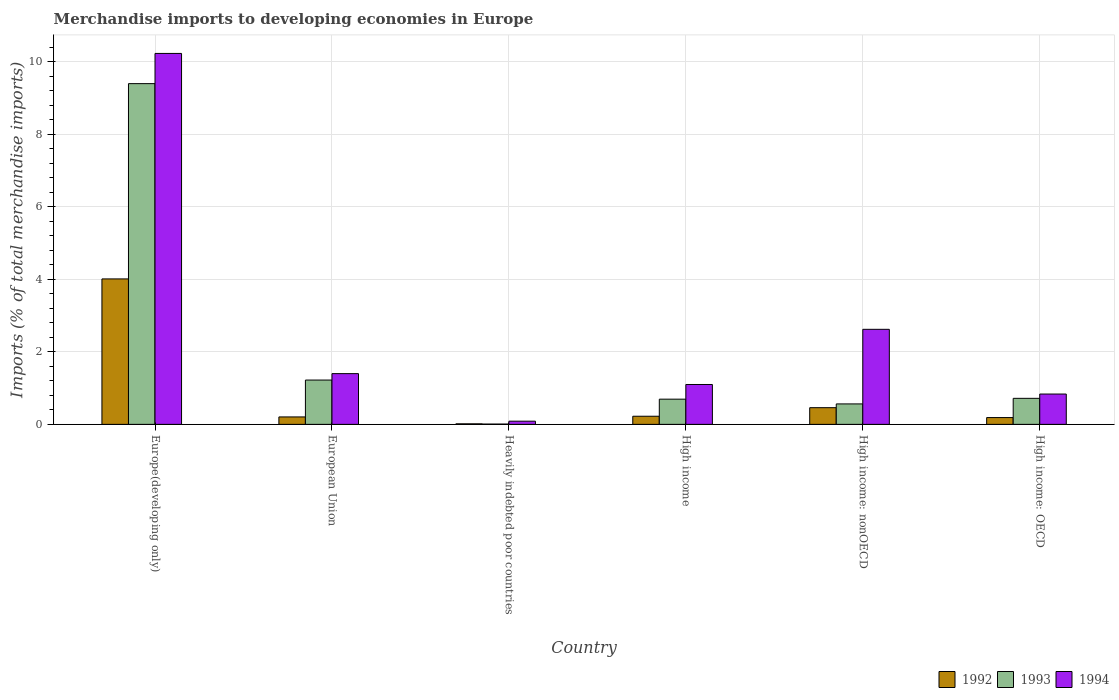How many different coloured bars are there?
Provide a short and direct response. 3. How many groups of bars are there?
Ensure brevity in your answer.  6. Are the number of bars per tick equal to the number of legend labels?
Give a very brief answer. Yes. Are the number of bars on each tick of the X-axis equal?
Offer a terse response. Yes. How many bars are there on the 4th tick from the left?
Keep it short and to the point. 3. In how many cases, is the number of bars for a given country not equal to the number of legend labels?
Your answer should be very brief. 0. What is the percentage total merchandise imports in 1994 in High income: OECD?
Keep it short and to the point. 0.84. Across all countries, what is the maximum percentage total merchandise imports in 1994?
Offer a terse response. 10.23. Across all countries, what is the minimum percentage total merchandise imports in 1993?
Your answer should be very brief. 0.01. In which country was the percentage total merchandise imports in 1992 maximum?
Give a very brief answer. Europe(developing only). In which country was the percentage total merchandise imports in 1993 minimum?
Keep it short and to the point. Heavily indebted poor countries. What is the total percentage total merchandise imports in 1994 in the graph?
Your response must be concise. 16.27. What is the difference between the percentage total merchandise imports in 1992 in European Union and that in High income?
Make the answer very short. -0.02. What is the difference between the percentage total merchandise imports in 1994 in High income and the percentage total merchandise imports in 1993 in Heavily indebted poor countries?
Your answer should be very brief. 1.09. What is the average percentage total merchandise imports in 1993 per country?
Your answer should be very brief. 2.1. What is the difference between the percentage total merchandise imports of/in 1992 and percentage total merchandise imports of/in 1994 in European Union?
Ensure brevity in your answer.  -1.19. In how many countries, is the percentage total merchandise imports in 1994 greater than 3.2 %?
Your response must be concise. 1. What is the ratio of the percentage total merchandise imports in 1994 in European Union to that in High income: nonOECD?
Your response must be concise. 0.53. What is the difference between the highest and the second highest percentage total merchandise imports in 1992?
Give a very brief answer. 0.24. What is the difference between the highest and the lowest percentage total merchandise imports in 1994?
Your response must be concise. 10.14. In how many countries, is the percentage total merchandise imports in 1992 greater than the average percentage total merchandise imports in 1992 taken over all countries?
Keep it short and to the point. 1. Is the sum of the percentage total merchandise imports in 1994 in European Union and High income greater than the maximum percentage total merchandise imports in 1993 across all countries?
Make the answer very short. No. What does the 3rd bar from the right in High income represents?
Keep it short and to the point. 1992. How many bars are there?
Provide a short and direct response. 18. Are all the bars in the graph horizontal?
Give a very brief answer. No. Are the values on the major ticks of Y-axis written in scientific E-notation?
Provide a succinct answer. No. Where does the legend appear in the graph?
Give a very brief answer. Bottom right. What is the title of the graph?
Offer a very short reply. Merchandise imports to developing economies in Europe. What is the label or title of the X-axis?
Keep it short and to the point. Country. What is the label or title of the Y-axis?
Offer a very short reply. Imports (% of total merchandise imports). What is the Imports (% of total merchandise imports) of 1992 in Europe(developing only)?
Provide a short and direct response. 4.01. What is the Imports (% of total merchandise imports) of 1993 in Europe(developing only)?
Your answer should be compact. 9.39. What is the Imports (% of total merchandise imports) in 1994 in Europe(developing only)?
Provide a short and direct response. 10.23. What is the Imports (% of total merchandise imports) of 1992 in European Union?
Offer a very short reply. 0.21. What is the Imports (% of total merchandise imports) in 1993 in European Union?
Your answer should be very brief. 1.22. What is the Imports (% of total merchandise imports) of 1994 in European Union?
Give a very brief answer. 1.4. What is the Imports (% of total merchandise imports) in 1992 in Heavily indebted poor countries?
Make the answer very short. 0.02. What is the Imports (% of total merchandise imports) of 1993 in Heavily indebted poor countries?
Your answer should be compact. 0.01. What is the Imports (% of total merchandise imports) in 1994 in Heavily indebted poor countries?
Provide a succinct answer. 0.09. What is the Imports (% of total merchandise imports) of 1992 in High income?
Keep it short and to the point. 0.22. What is the Imports (% of total merchandise imports) of 1993 in High income?
Give a very brief answer. 0.7. What is the Imports (% of total merchandise imports) of 1994 in High income?
Provide a succinct answer. 1.1. What is the Imports (% of total merchandise imports) in 1992 in High income: nonOECD?
Provide a short and direct response. 0.46. What is the Imports (% of total merchandise imports) of 1993 in High income: nonOECD?
Your answer should be very brief. 0.56. What is the Imports (% of total merchandise imports) in 1994 in High income: nonOECD?
Make the answer very short. 2.62. What is the Imports (% of total merchandise imports) in 1992 in High income: OECD?
Your answer should be very brief. 0.19. What is the Imports (% of total merchandise imports) of 1993 in High income: OECD?
Offer a terse response. 0.72. What is the Imports (% of total merchandise imports) in 1994 in High income: OECD?
Your response must be concise. 0.84. Across all countries, what is the maximum Imports (% of total merchandise imports) in 1992?
Provide a succinct answer. 4.01. Across all countries, what is the maximum Imports (% of total merchandise imports) in 1993?
Ensure brevity in your answer.  9.39. Across all countries, what is the maximum Imports (% of total merchandise imports) in 1994?
Keep it short and to the point. 10.23. Across all countries, what is the minimum Imports (% of total merchandise imports) of 1992?
Offer a very short reply. 0.02. Across all countries, what is the minimum Imports (% of total merchandise imports) in 1993?
Your response must be concise. 0.01. Across all countries, what is the minimum Imports (% of total merchandise imports) in 1994?
Ensure brevity in your answer.  0.09. What is the total Imports (% of total merchandise imports) in 1992 in the graph?
Ensure brevity in your answer.  5.1. What is the total Imports (% of total merchandise imports) in 1993 in the graph?
Your response must be concise. 12.6. What is the total Imports (% of total merchandise imports) in 1994 in the graph?
Give a very brief answer. 16.27. What is the difference between the Imports (% of total merchandise imports) of 1992 in Europe(developing only) and that in European Union?
Keep it short and to the point. 3.8. What is the difference between the Imports (% of total merchandise imports) in 1993 in Europe(developing only) and that in European Union?
Your response must be concise. 8.17. What is the difference between the Imports (% of total merchandise imports) in 1994 in Europe(developing only) and that in European Union?
Keep it short and to the point. 8.83. What is the difference between the Imports (% of total merchandise imports) of 1992 in Europe(developing only) and that in Heavily indebted poor countries?
Your answer should be very brief. 4. What is the difference between the Imports (% of total merchandise imports) of 1993 in Europe(developing only) and that in Heavily indebted poor countries?
Your answer should be very brief. 9.39. What is the difference between the Imports (% of total merchandise imports) in 1994 in Europe(developing only) and that in Heavily indebted poor countries?
Give a very brief answer. 10.14. What is the difference between the Imports (% of total merchandise imports) of 1992 in Europe(developing only) and that in High income?
Provide a short and direct response. 3.79. What is the difference between the Imports (% of total merchandise imports) in 1993 in Europe(developing only) and that in High income?
Offer a terse response. 8.7. What is the difference between the Imports (% of total merchandise imports) of 1994 in Europe(developing only) and that in High income?
Provide a succinct answer. 9.13. What is the difference between the Imports (% of total merchandise imports) in 1992 in Europe(developing only) and that in High income: nonOECD?
Make the answer very short. 3.55. What is the difference between the Imports (% of total merchandise imports) in 1993 in Europe(developing only) and that in High income: nonOECD?
Keep it short and to the point. 8.83. What is the difference between the Imports (% of total merchandise imports) of 1994 in Europe(developing only) and that in High income: nonOECD?
Your answer should be compact. 7.61. What is the difference between the Imports (% of total merchandise imports) of 1992 in Europe(developing only) and that in High income: OECD?
Provide a succinct answer. 3.82. What is the difference between the Imports (% of total merchandise imports) of 1993 in Europe(developing only) and that in High income: OECD?
Provide a short and direct response. 8.68. What is the difference between the Imports (% of total merchandise imports) of 1994 in Europe(developing only) and that in High income: OECD?
Provide a short and direct response. 9.39. What is the difference between the Imports (% of total merchandise imports) in 1992 in European Union and that in Heavily indebted poor countries?
Provide a succinct answer. 0.19. What is the difference between the Imports (% of total merchandise imports) in 1993 in European Union and that in Heavily indebted poor countries?
Your response must be concise. 1.21. What is the difference between the Imports (% of total merchandise imports) in 1994 in European Union and that in Heavily indebted poor countries?
Offer a terse response. 1.31. What is the difference between the Imports (% of total merchandise imports) in 1992 in European Union and that in High income?
Offer a terse response. -0.02. What is the difference between the Imports (% of total merchandise imports) in 1993 in European Union and that in High income?
Ensure brevity in your answer.  0.53. What is the difference between the Imports (% of total merchandise imports) of 1994 in European Union and that in High income?
Offer a very short reply. 0.3. What is the difference between the Imports (% of total merchandise imports) of 1992 in European Union and that in High income: nonOECD?
Make the answer very short. -0.25. What is the difference between the Imports (% of total merchandise imports) of 1993 in European Union and that in High income: nonOECD?
Provide a succinct answer. 0.66. What is the difference between the Imports (% of total merchandise imports) in 1994 in European Union and that in High income: nonOECD?
Provide a succinct answer. -1.22. What is the difference between the Imports (% of total merchandise imports) of 1992 in European Union and that in High income: OECD?
Provide a succinct answer. 0.02. What is the difference between the Imports (% of total merchandise imports) of 1993 in European Union and that in High income: OECD?
Keep it short and to the point. 0.5. What is the difference between the Imports (% of total merchandise imports) in 1994 in European Union and that in High income: OECD?
Ensure brevity in your answer.  0.56. What is the difference between the Imports (% of total merchandise imports) in 1992 in Heavily indebted poor countries and that in High income?
Offer a very short reply. -0.21. What is the difference between the Imports (% of total merchandise imports) of 1993 in Heavily indebted poor countries and that in High income?
Your answer should be very brief. -0.69. What is the difference between the Imports (% of total merchandise imports) in 1994 in Heavily indebted poor countries and that in High income?
Ensure brevity in your answer.  -1.01. What is the difference between the Imports (% of total merchandise imports) in 1992 in Heavily indebted poor countries and that in High income: nonOECD?
Provide a short and direct response. -0.45. What is the difference between the Imports (% of total merchandise imports) of 1993 in Heavily indebted poor countries and that in High income: nonOECD?
Provide a short and direct response. -0.56. What is the difference between the Imports (% of total merchandise imports) of 1994 in Heavily indebted poor countries and that in High income: nonOECD?
Your answer should be very brief. -2.53. What is the difference between the Imports (% of total merchandise imports) in 1992 in Heavily indebted poor countries and that in High income: OECD?
Your answer should be very brief. -0.17. What is the difference between the Imports (% of total merchandise imports) of 1993 in Heavily indebted poor countries and that in High income: OECD?
Keep it short and to the point. -0.71. What is the difference between the Imports (% of total merchandise imports) in 1994 in Heavily indebted poor countries and that in High income: OECD?
Offer a very short reply. -0.75. What is the difference between the Imports (% of total merchandise imports) in 1992 in High income and that in High income: nonOECD?
Provide a short and direct response. -0.24. What is the difference between the Imports (% of total merchandise imports) in 1993 in High income and that in High income: nonOECD?
Keep it short and to the point. 0.13. What is the difference between the Imports (% of total merchandise imports) of 1994 in High income and that in High income: nonOECD?
Offer a terse response. -1.52. What is the difference between the Imports (% of total merchandise imports) in 1992 in High income and that in High income: OECD?
Your response must be concise. 0.04. What is the difference between the Imports (% of total merchandise imports) in 1993 in High income and that in High income: OECD?
Provide a succinct answer. -0.02. What is the difference between the Imports (% of total merchandise imports) in 1994 in High income and that in High income: OECD?
Offer a very short reply. 0.26. What is the difference between the Imports (% of total merchandise imports) of 1992 in High income: nonOECD and that in High income: OECD?
Your answer should be compact. 0.27. What is the difference between the Imports (% of total merchandise imports) of 1993 in High income: nonOECD and that in High income: OECD?
Keep it short and to the point. -0.15. What is the difference between the Imports (% of total merchandise imports) in 1994 in High income: nonOECD and that in High income: OECD?
Provide a succinct answer. 1.78. What is the difference between the Imports (% of total merchandise imports) in 1992 in Europe(developing only) and the Imports (% of total merchandise imports) in 1993 in European Union?
Your answer should be compact. 2.79. What is the difference between the Imports (% of total merchandise imports) of 1992 in Europe(developing only) and the Imports (% of total merchandise imports) of 1994 in European Union?
Offer a terse response. 2.61. What is the difference between the Imports (% of total merchandise imports) in 1993 in Europe(developing only) and the Imports (% of total merchandise imports) in 1994 in European Union?
Provide a succinct answer. 8. What is the difference between the Imports (% of total merchandise imports) of 1992 in Europe(developing only) and the Imports (% of total merchandise imports) of 1993 in Heavily indebted poor countries?
Your answer should be very brief. 4. What is the difference between the Imports (% of total merchandise imports) of 1992 in Europe(developing only) and the Imports (% of total merchandise imports) of 1994 in Heavily indebted poor countries?
Provide a short and direct response. 3.92. What is the difference between the Imports (% of total merchandise imports) in 1993 in Europe(developing only) and the Imports (% of total merchandise imports) in 1994 in Heavily indebted poor countries?
Your answer should be very brief. 9.31. What is the difference between the Imports (% of total merchandise imports) of 1992 in Europe(developing only) and the Imports (% of total merchandise imports) of 1993 in High income?
Make the answer very short. 3.32. What is the difference between the Imports (% of total merchandise imports) in 1992 in Europe(developing only) and the Imports (% of total merchandise imports) in 1994 in High income?
Ensure brevity in your answer.  2.91. What is the difference between the Imports (% of total merchandise imports) in 1993 in Europe(developing only) and the Imports (% of total merchandise imports) in 1994 in High income?
Provide a short and direct response. 8.29. What is the difference between the Imports (% of total merchandise imports) of 1992 in Europe(developing only) and the Imports (% of total merchandise imports) of 1993 in High income: nonOECD?
Your response must be concise. 3.45. What is the difference between the Imports (% of total merchandise imports) in 1992 in Europe(developing only) and the Imports (% of total merchandise imports) in 1994 in High income: nonOECD?
Make the answer very short. 1.39. What is the difference between the Imports (% of total merchandise imports) of 1993 in Europe(developing only) and the Imports (% of total merchandise imports) of 1994 in High income: nonOECD?
Your answer should be compact. 6.77. What is the difference between the Imports (% of total merchandise imports) of 1992 in Europe(developing only) and the Imports (% of total merchandise imports) of 1993 in High income: OECD?
Keep it short and to the point. 3.29. What is the difference between the Imports (% of total merchandise imports) in 1992 in Europe(developing only) and the Imports (% of total merchandise imports) in 1994 in High income: OECD?
Your response must be concise. 3.17. What is the difference between the Imports (% of total merchandise imports) in 1993 in Europe(developing only) and the Imports (% of total merchandise imports) in 1994 in High income: OECD?
Offer a terse response. 8.56. What is the difference between the Imports (% of total merchandise imports) in 1992 in European Union and the Imports (% of total merchandise imports) in 1993 in Heavily indebted poor countries?
Make the answer very short. 0.2. What is the difference between the Imports (% of total merchandise imports) in 1992 in European Union and the Imports (% of total merchandise imports) in 1994 in Heavily indebted poor countries?
Offer a very short reply. 0.12. What is the difference between the Imports (% of total merchandise imports) in 1993 in European Union and the Imports (% of total merchandise imports) in 1994 in Heavily indebted poor countries?
Keep it short and to the point. 1.13. What is the difference between the Imports (% of total merchandise imports) of 1992 in European Union and the Imports (% of total merchandise imports) of 1993 in High income?
Your response must be concise. -0.49. What is the difference between the Imports (% of total merchandise imports) of 1992 in European Union and the Imports (% of total merchandise imports) of 1994 in High income?
Provide a short and direct response. -0.89. What is the difference between the Imports (% of total merchandise imports) in 1993 in European Union and the Imports (% of total merchandise imports) in 1994 in High income?
Your response must be concise. 0.12. What is the difference between the Imports (% of total merchandise imports) of 1992 in European Union and the Imports (% of total merchandise imports) of 1993 in High income: nonOECD?
Your answer should be very brief. -0.36. What is the difference between the Imports (% of total merchandise imports) in 1992 in European Union and the Imports (% of total merchandise imports) in 1994 in High income: nonOECD?
Provide a succinct answer. -2.42. What is the difference between the Imports (% of total merchandise imports) of 1993 in European Union and the Imports (% of total merchandise imports) of 1994 in High income: nonOECD?
Offer a terse response. -1.4. What is the difference between the Imports (% of total merchandise imports) in 1992 in European Union and the Imports (% of total merchandise imports) in 1993 in High income: OECD?
Your response must be concise. -0.51. What is the difference between the Imports (% of total merchandise imports) of 1992 in European Union and the Imports (% of total merchandise imports) of 1994 in High income: OECD?
Provide a succinct answer. -0.63. What is the difference between the Imports (% of total merchandise imports) in 1993 in European Union and the Imports (% of total merchandise imports) in 1994 in High income: OECD?
Keep it short and to the point. 0.39. What is the difference between the Imports (% of total merchandise imports) in 1992 in Heavily indebted poor countries and the Imports (% of total merchandise imports) in 1993 in High income?
Ensure brevity in your answer.  -0.68. What is the difference between the Imports (% of total merchandise imports) in 1992 in Heavily indebted poor countries and the Imports (% of total merchandise imports) in 1994 in High income?
Your answer should be very brief. -1.08. What is the difference between the Imports (% of total merchandise imports) of 1993 in Heavily indebted poor countries and the Imports (% of total merchandise imports) of 1994 in High income?
Ensure brevity in your answer.  -1.09. What is the difference between the Imports (% of total merchandise imports) of 1992 in Heavily indebted poor countries and the Imports (% of total merchandise imports) of 1993 in High income: nonOECD?
Offer a very short reply. -0.55. What is the difference between the Imports (% of total merchandise imports) in 1992 in Heavily indebted poor countries and the Imports (% of total merchandise imports) in 1994 in High income: nonOECD?
Your answer should be very brief. -2.61. What is the difference between the Imports (% of total merchandise imports) in 1993 in Heavily indebted poor countries and the Imports (% of total merchandise imports) in 1994 in High income: nonOECD?
Give a very brief answer. -2.61. What is the difference between the Imports (% of total merchandise imports) in 1992 in Heavily indebted poor countries and the Imports (% of total merchandise imports) in 1993 in High income: OECD?
Give a very brief answer. -0.7. What is the difference between the Imports (% of total merchandise imports) of 1992 in Heavily indebted poor countries and the Imports (% of total merchandise imports) of 1994 in High income: OECD?
Make the answer very short. -0.82. What is the difference between the Imports (% of total merchandise imports) of 1993 in Heavily indebted poor countries and the Imports (% of total merchandise imports) of 1994 in High income: OECD?
Your answer should be very brief. -0.83. What is the difference between the Imports (% of total merchandise imports) in 1992 in High income and the Imports (% of total merchandise imports) in 1993 in High income: nonOECD?
Your answer should be compact. -0.34. What is the difference between the Imports (% of total merchandise imports) of 1992 in High income and the Imports (% of total merchandise imports) of 1994 in High income: nonOECD?
Provide a succinct answer. -2.4. What is the difference between the Imports (% of total merchandise imports) of 1993 in High income and the Imports (% of total merchandise imports) of 1994 in High income: nonOECD?
Your answer should be compact. -1.93. What is the difference between the Imports (% of total merchandise imports) of 1992 in High income and the Imports (% of total merchandise imports) of 1993 in High income: OECD?
Keep it short and to the point. -0.49. What is the difference between the Imports (% of total merchandise imports) of 1992 in High income and the Imports (% of total merchandise imports) of 1994 in High income: OECD?
Provide a succinct answer. -0.61. What is the difference between the Imports (% of total merchandise imports) in 1993 in High income and the Imports (% of total merchandise imports) in 1994 in High income: OECD?
Ensure brevity in your answer.  -0.14. What is the difference between the Imports (% of total merchandise imports) of 1992 in High income: nonOECD and the Imports (% of total merchandise imports) of 1993 in High income: OECD?
Give a very brief answer. -0.26. What is the difference between the Imports (% of total merchandise imports) of 1992 in High income: nonOECD and the Imports (% of total merchandise imports) of 1994 in High income: OECD?
Keep it short and to the point. -0.38. What is the difference between the Imports (% of total merchandise imports) in 1993 in High income: nonOECD and the Imports (% of total merchandise imports) in 1994 in High income: OECD?
Make the answer very short. -0.27. What is the average Imports (% of total merchandise imports) in 1992 per country?
Give a very brief answer. 0.85. What is the average Imports (% of total merchandise imports) in 1993 per country?
Keep it short and to the point. 2.1. What is the average Imports (% of total merchandise imports) in 1994 per country?
Ensure brevity in your answer.  2.71. What is the difference between the Imports (% of total merchandise imports) in 1992 and Imports (% of total merchandise imports) in 1993 in Europe(developing only)?
Give a very brief answer. -5.38. What is the difference between the Imports (% of total merchandise imports) in 1992 and Imports (% of total merchandise imports) in 1994 in Europe(developing only)?
Offer a terse response. -6.22. What is the difference between the Imports (% of total merchandise imports) of 1993 and Imports (% of total merchandise imports) of 1994 in Europe(developing only)?
Ensure brevity in your answer.  -0.83. What is the difference between the Imports (% of total merchandise imports) of 1992 and Imports (% of total merchandise imports) of 1993 in European Union?
Provide a succinct answer. -1.02. What is the difference between the Imports (% of total merchandise imports) of 1992 and Imports (% of total merchandise imports) of 1994 in European Union?
Offer a terse response. -1.19. What is the difference between the Imports (% of total merchandise imports) of 1993 and Imports (% of total merchandise imports) of 1994 in European Union?
Keep it short and to the point. -0.18. What is the difference between the Imports (% of total merchandise imports) of 1992 and Imports (% of total merchandise imports) of 1993 in Heavily indebted poor countries?
Your answer should be very brief. 0.01. What is the difference between the Imports (% of total merchandise imports) in 1992 and Imports (% of total merchandise imports) in 1994 in Heavily indebted poor countries?
Provide a short and direct response. -0.07. What is the difference between the Imports (% of total merchandise imports) in 1993 and Imports (% of total merchandise imports) in 1994 in Heavily indebted poor countries?
Provide a short and direct response. -0.08. What is the difference between the Imports (% of total merchandise imports) of 1992 and Imports (% of total merchandise imports) of 1993 in High income?
Make the answer very short. -0.47. What is the difference between the Imports (% of total merchandise imports) in 1992 and Imports (% of total merchandise imports) in 1994 in High income?
Ensure brevity in your answer.  -0.88. What is the difference between the Imports (% of total merchandise imports) in 1993 and Imports (% of total merchandise imports) in 1994 in High income?
Make the answer very short. -0.4. What is the difference between the Imports (% of total merchandise imports) in 1992 and Imports (% of total merchandise imports) in 1993 in High income: nonOECD?
Provide a short and direct response. -0.1. What is the difference between the Imports (% of total merchandise imports) of 1992 and Imports (% of total merchandise imports) of 1994 in High income: nonOECD?
Offer a terse response. -2.16. What is the difference between the Imports (% of total merchandise imports) of 1993 and Imports (% of total merchandise imports) of 1994 in High income: nonOECD?
Ensure brevity in your answer.  -2.06. What is the difference between the Imports (% of total merchandise imports) in 1992 and Imports (% of total merchandise imports) in 1993 in High income: OECD?
Provide a succinct answer. -0.53. What is the difference between the Imports (% of total merchandise imports) in 1992 and Imports (% of total merchandise imports) in 1994 in High income: OECD?
Ensure brevity in your answer.  -0.65. What is the difference between the Imports (% of total merchandise imports) of 1993 and Imports (% of total merchandise imports) of 1994 in High income: OECD?
Offer a terse response. -0.12. What is the ratio of the Imports (% of total merchandise imports) in 1992 in Europe(developing only) to that in European Union?
Provide a short and direct response. 19.52. What is the ratio of the Imports (% of total merchandise imports) of 1993 in Europe(developing only) to that in European Union?
Keep it short and to the point. 7.69. What is the ratio of the Imports (% of total merchandise imports) of 1994 in Europe(developing only) to that in European Union?
Your answer should be compact. 7.31. What is the ratio of the Imports (% of total merchandise imports) in 1992 in Europe(developing only) to that in Heavily indebted poor countries?
Make the answer very short. 265.61. What is the ratio of the Imports (% of total merchandise imports) in 1993 in Europe(developing only) to that in Heavily indebted poor countries?
Ensure brevity in your answer.  1135.41. What is the ratio of the Imports (% of total merchandise imports) in 1994 in Europe(developing only) to that in Heavily indebted poor countries?
Give a very brief answer. 116.26. What is the ratio of the Imports (% of total merchandise imports) in 1992 in Europe(developing only) to that in High income?
Your answer should be very brief. 17.88. What is the ratio of the Imports (% of total merchandise imports) in 1993 in Europe(developing only) to that in High income?
Give a very brief answer. 13.51. What is the ratio of the Imports (% of total merchandise imports) of 1994 in Europe(developing only) to that in High income?
Provide a succinct answer. 9.3. What is the ratio of the Imports (% of total merchandise imports) of 1992 in Europe(developing only) to that in High income: nonOECD?
Offer a very short reply. 8.71. What is the ratio of the Imports (% of total merchandise imports) of 1993 in Europe(developing only) to that in High income: nonOECD?
Offer a terse response. 16.66. What is the ratio of the Imports (% of total merchandise imports) of 1994 in Europe(developing only) to that in High income: nonOECD?
Keep it short and to the point. 3.9. What is the ratio of the Imports (% of total merchandise imports) of 1992 in Europe(developing only) to that in High income: OECD?
Offer a terse response. 21.36. What is the ratio of the Imports (% of total merchandise imports) in 1993 in Europe(developing only) to that in High income: OECD?
Your response must be concise. 13.08. What is the ratio of the Imports (% of total merchandise imports) in 1994 in Europe(developing only) to that in High income: OECD?
Offer a terse response. 12.23. What is the ratio of the Imports (% of total merchandise imports) of 1992 in European Union to that in Heavily indebted poor countries?
Your answer should be very brief. 13.61. What is the ratio of the Imports (% of total merchandise imports) in 1993 in European Union to that in Heavily indebted poor countries?
Make the answer very short. 147.67. What is the ratio of the Imports (% of total merchandise imports) of 1994 in European Union to that in Heavily indebted poor countries?
Ensure brevity in your answer.  15.9. What is the ratio of the Imports (% of total merchandise imports) in 1992 in European Union to that in High income?
Your answer should be very brief. 0.92. What is the ratio of the Imports (% of total merchandise imports) of 1993 in European Union to that in High income?
Give a very brief answer. 1.76. What is the ratio of the Imports (% of total merchandise imports) of 1994 in European Union to that in High income?
Ensure brevity in your answer.  1.27. What is the ratio of the Imports (% of total merchandise imports) of 1992 in European Union to that in High income: nonOECD?
Ensure brevity in your answer.  0.45. What is the ratio of the Imports (% of total merchandise imports) in 1993 in European Union to that in High income: nonOECD?
Your answer should be compact. 2.17. What is the ratio of the Imports (% of total merchandise imports) of 1994 in European Union to that in High income: nonOECD?
Keep it short and to the point. 0.53. What is the ratio of the Imports (% of total merchandise imports) in 1992 in European Union to that in High income: OECD?
Keep it short and to the point. 1.09. What is the ratio of the Imports (% of total merchandise imports) in 1993 in European Union to that in High income: OECD?
Provide a short and direct response. 1.7. What is the ratio of the Imports (% of total merchandise imports) of 1994 in European Union to that in High income: OECD?
Your answer should be compact. 1.67. What is the ratio of the Imports (% of total merchandise imports) in 1992 in Heavily indebted poor countries to that in High income?
Give a very brief answer. 0.07. What is the ratio of the Imports (% of total merchandise imports) in 1993 in Heavily indebted poor countries to that in High income?
Your answer should be compact. 0.01. What is the ratio of the Imports (% of total merchandise imports) in 1992 in Heavily indebted poor countries to that in High income: nonOECD?
Provide a short and direct response. 0.03. What is the ratio of the Imports (% of total merchandise imports) in 1993 in Heavily indebted poor countries to that in High income: nonOECD?
Offer a terse response. 0.01. What is the ratio of the Imports (% of total merchandise imports) of 1994 in Heavily indebted poor countries to that in High income: nonOECD?
Offer a very short reply. 0.03. What is the ratio of the Imports (% of total merchandise imports) in 1992 in Heavily indebted poor countries to that in High income: OECD?
Keep it short and to the point. 0.08. What is the ratio of the Imports (% of total merchandise imports) of 1993 in Heavily indebted poor countries to that in High income: OECD?
Offer a terse response. 0.01. What is the ratio of the Imports (% of total merchandise imports) of 1994 in Heavily indebted poor countries to that in High income: OECD?
Offer a very short reply. 0.11. What is the ratio of the Imports (% of total merchandise imports) of 1992 in High income to that in High income: nonOECD?
Keep it short and to the point. 0.49. What is the ratio of the Imports (% of total merchandise imports) in 1993 in High income to that in High income: nonOECD?
Give a very brief answer. 1.23. What is the ratio of the Imports (% of total merchandise imports) in 1994 in High income to that in High income: nonOECD?
Offer a terse response. 0.42. What is the ratio of the Imports (% of total merchandise imports) in 1992 in High income to that in High income: OECD?
Your answer should be very brief. 1.19. What is the ratio of the Imports (% of total merchandise imports) of 1993 in High income to that in High income: OECD?
Make the answer very short. 0.97. What is the ratio of the Imports (% of total merchandise imports) of 1994 in High income to that in High income: OECD?
Provide a succinct answer. 1.31. What is the ratio of the Imports (% of total merchandise imports) of 1992 in High income: nonOECD to that in High income: OECD?
Provide a succinct answer. 2.45. What is the ratio of the Imports (% of total merchandise imports) of 1993 in High income: nonOECD to that in High income: OECD?
Your answer should be very brief. 0.79. What is the ratio of the Imports (% of total merchandise imports) of 1994 in High income: nonOECD to that in High income: OECD?
Your answer should be compact. 3.13. What is the difference between the highest and the second highest Imports (% of total merchandise imports) in 1992?
Ensure brevity in your answer.  3.55. What is the difference between the highest and the second highest Imports (% of total merchandise imports) of 1993?
Your answer should be very brief. 8.17. What is the difference between the highest and the second highest Imports (% of total merchandise imports) of 1994?
Your answer should be very brief. 7.61. What is the difference between the highest and the lowest Imports (% of total merchandise imports) of 1992?
Your response must be concise. 4. What is the difference between the highest and the lowest Imports (% of total merchandise imports) in 1993?
Provide a succinct answer. 9.39. What is the difference between the highest and the lowest Imports (% of total merchandise imports) of 1994?
Provide a succinct answer. 10.14. 